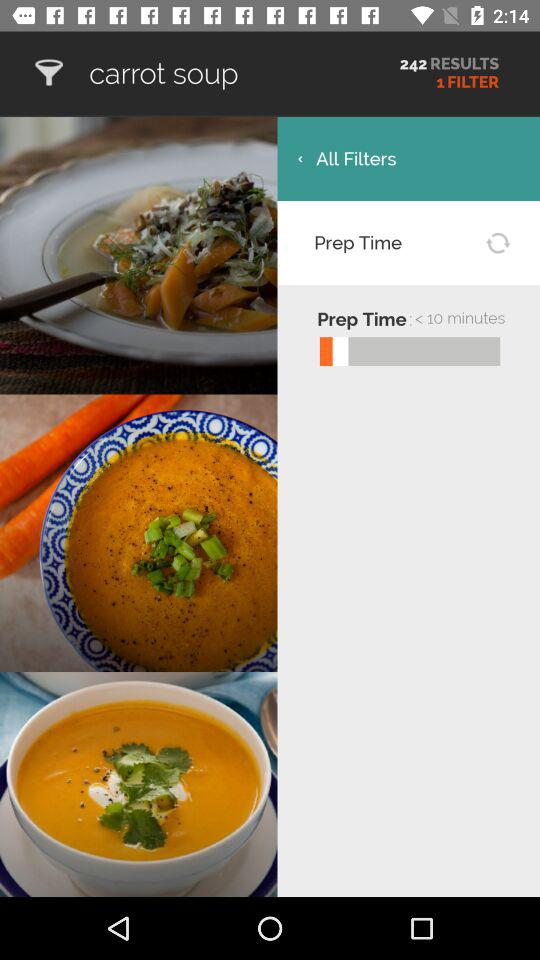How many filters are applied? There is one filter applied. 